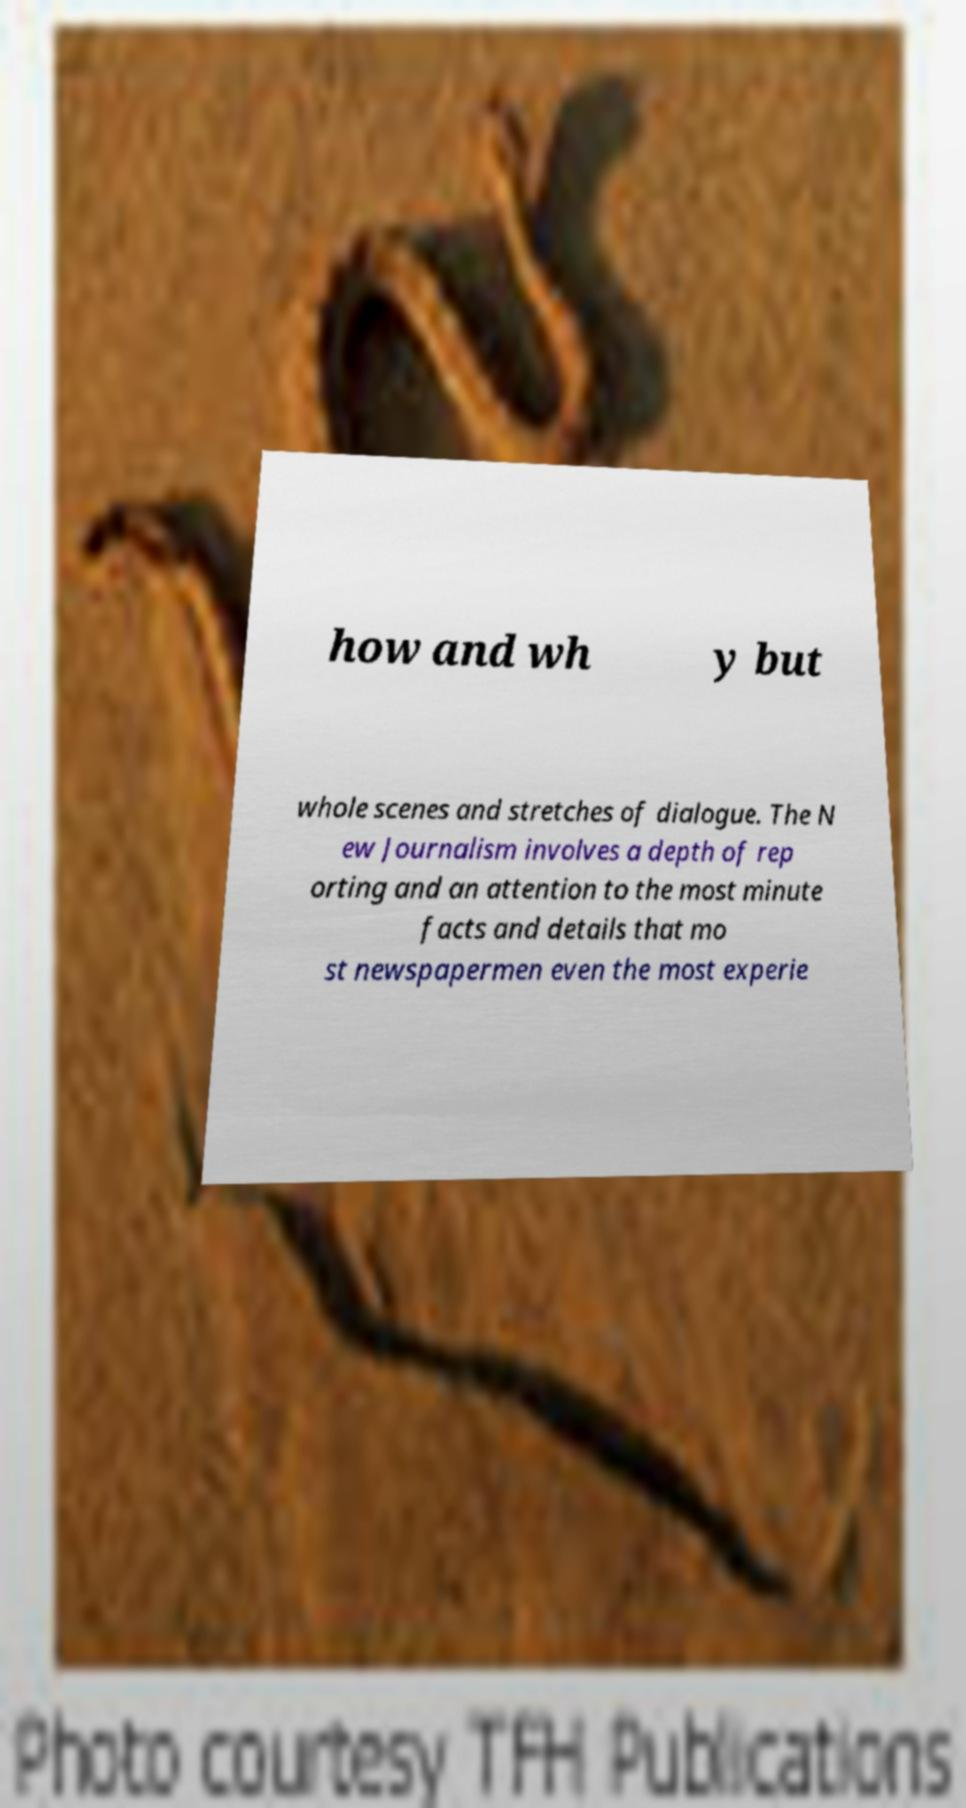Can you read and provide the text displayed in the image?This photo seems to have some interesting text. Can you extract and type it out for me? how and wh y but whole scenes and stretches of dialogue. The N ew Journalism involves a depth of rep orting and an attention to the most minute facts and details that mo st newspapermen even the most experie 